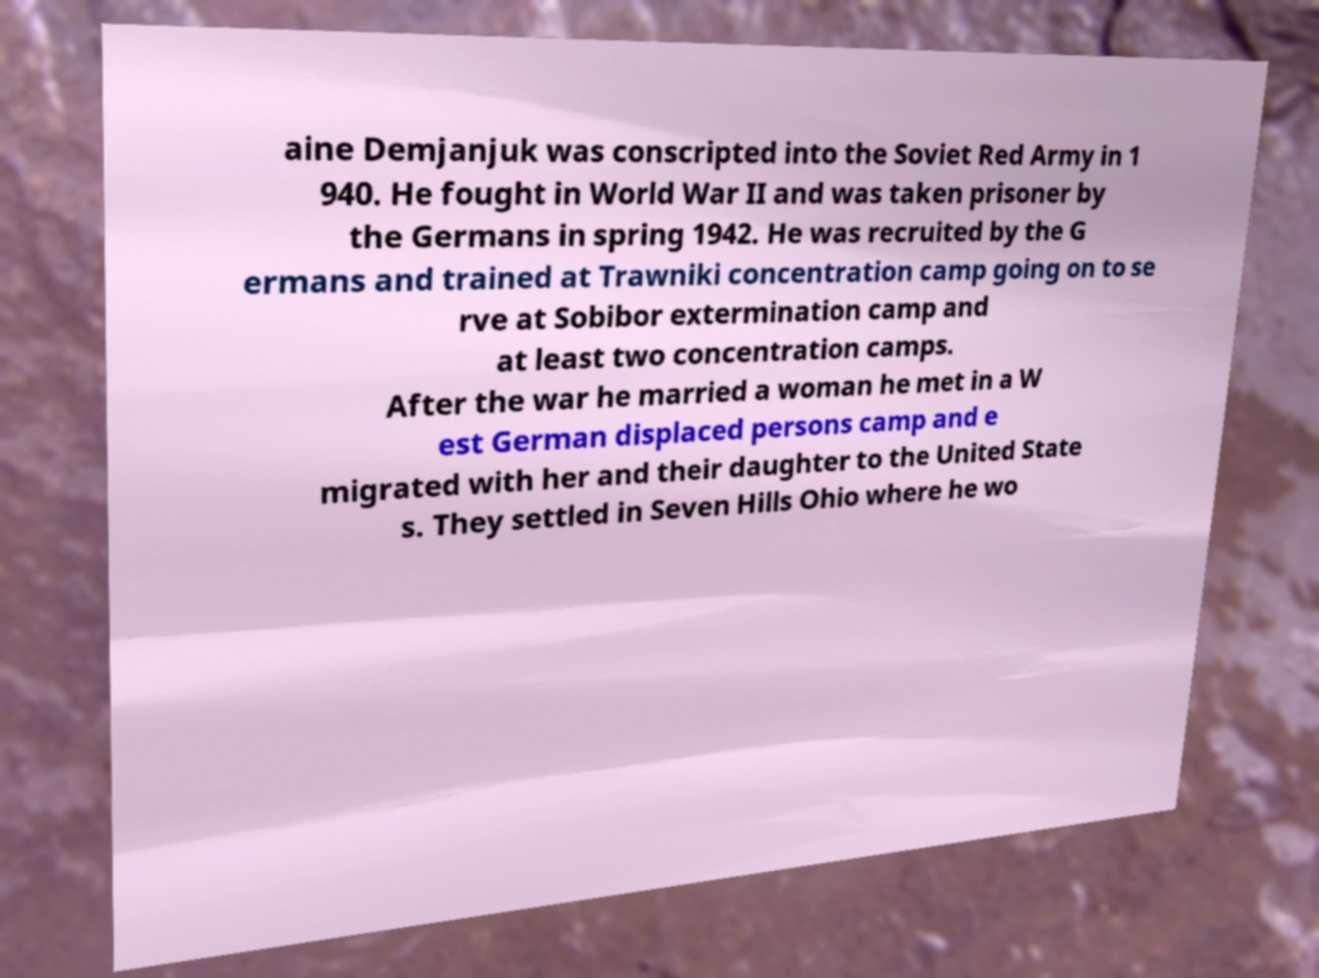Please identify and transcribe the text found in this image. aine Demjanjuk was conscripted into the Soviet Red Army in 1 940. He fought in World War II and was taken prisoner by the Germans in spring 1942. He was recruited by the G ermans and trained at Trawniki concentration camp going on to se rve at Sobibor extermination camp and at least two concentration camps. After the war he married a woman he met in a W est German displaced persons camp and e migrated with her and their daughter to the United State s. They settled in Seven Hills Ohio where he wo 